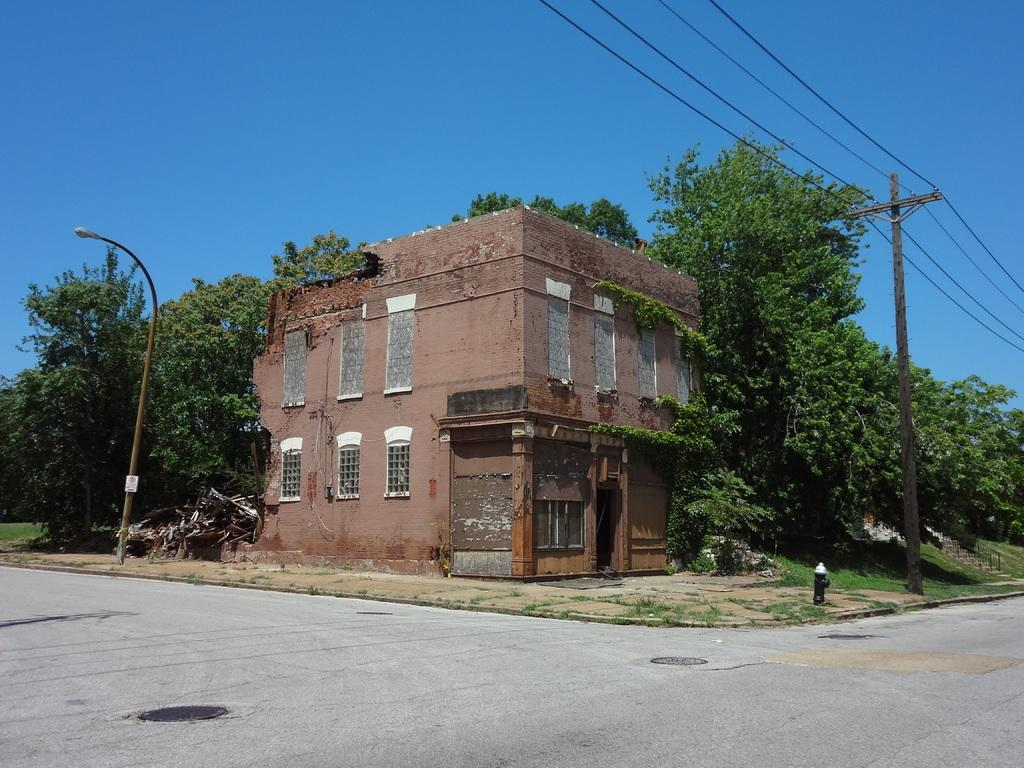What type of structure is present in the image? There is a building in the image. Can you describe the color of the building? The building is brown. What other natural elements can be seen in the image? There are trees in the image. What is the color of the trees? The trees are green. Are there any man-made structures besides the building in the image? Yes, there is an electric pole and a light pole in the image. What is the color of the sky in the image? The sky is blue. Can you see a servant holding a rifle in the image? There is no servant or rifle present in the image. What type of board is being used by the people in the image? There are no people or boards present in the image. 